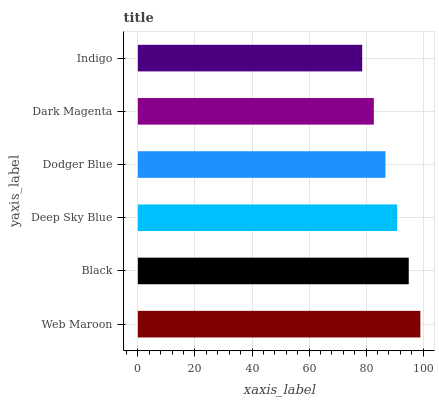Is Indigo the minimum?
Answer yes or no. Yes. Is Web Maroon the maximum?
Answer yes or no. Yes. Is Black the minimum?
Answer yes or no. No. Is Black the maximum?
Answer yes or no. No. Is Web Maroon greater than Black?
Answer yes or no. Yes. Is Black less than Web Maroon?
Answer yes or no. Yes. Is Black greater than Web Maroon?
Answer yes or no. No. Is Web Maroon less than Black?
Answer yes or no. No. Is Deep Sky Blue the high median?
Answer yes or no. Yes. Is Dodger Blue the low median?
Answer yes or no. Yes. Is Dodger Blue the high median?
Answer yes or no. No. Is Web Maroon the low median?
Answer yes or no. No. 